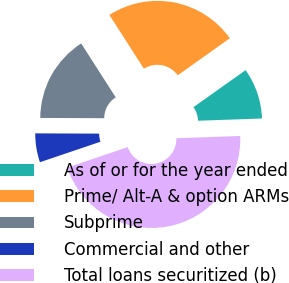Convert chart. <chart><loc_0><loc_0><loc_500><loc_500><pie_chart><fcel>As of or for the year ended<fcel>Prime/ Alt-A & option ARMs<fcel>Subprime<fcel>Commercial and other<fcel>Total loans securitized (b)<nl><fcel>9.27%<fcel>24.24%<fcel>15.86%<fcel>5.26%<fcel>45.36%<nl></chart> 